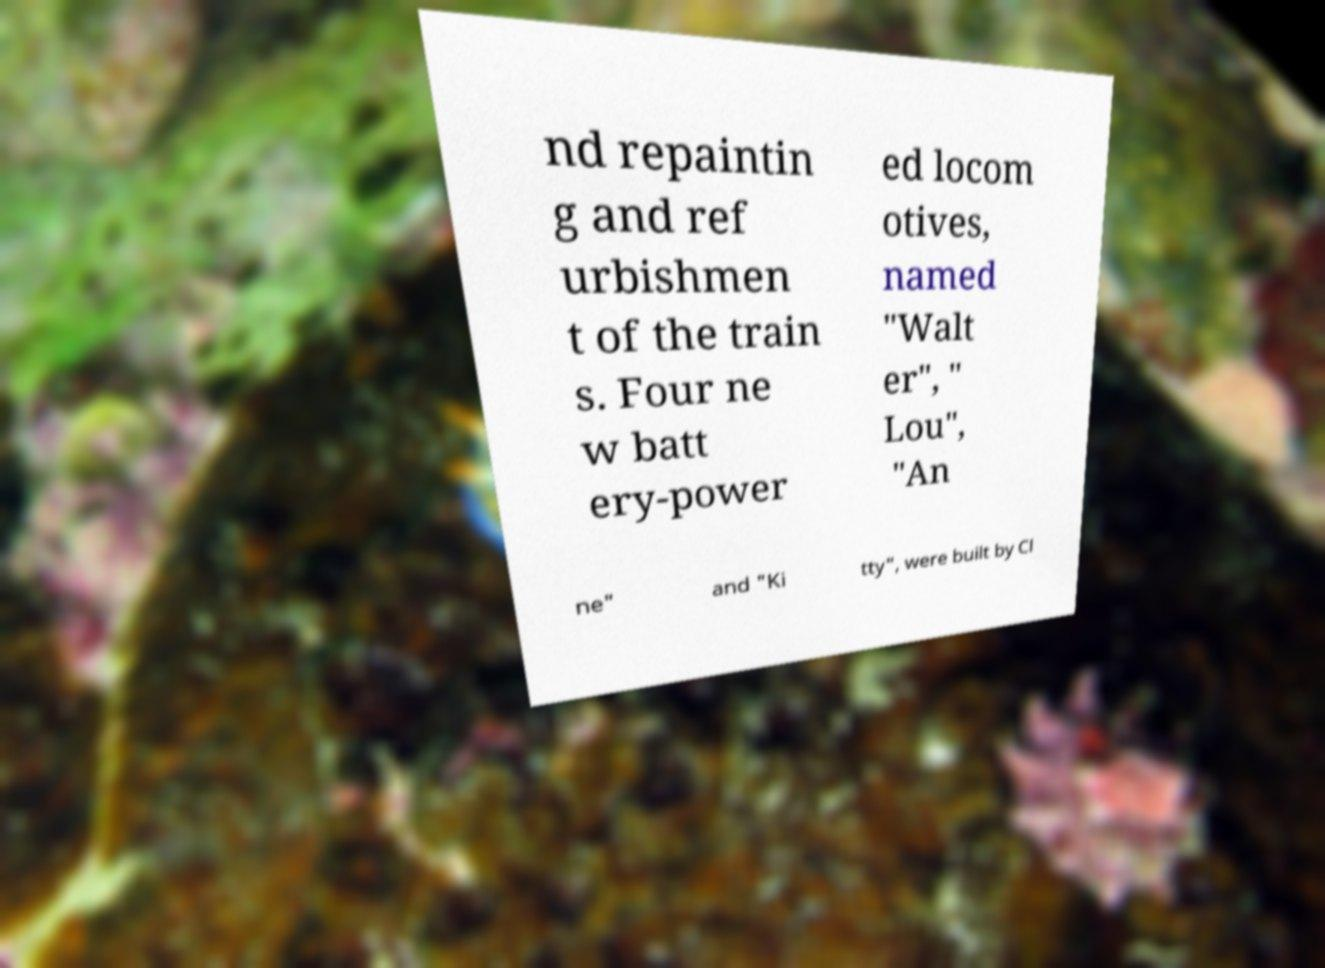Please read and relay the text visible in this image. What does it say? nd repaintin g and ref urbishmen t of the train s. Four ne w batt ery-power ed locom otives, named "Walt er", " Lou", "An ne" and "Ki tty", were built by Cl 